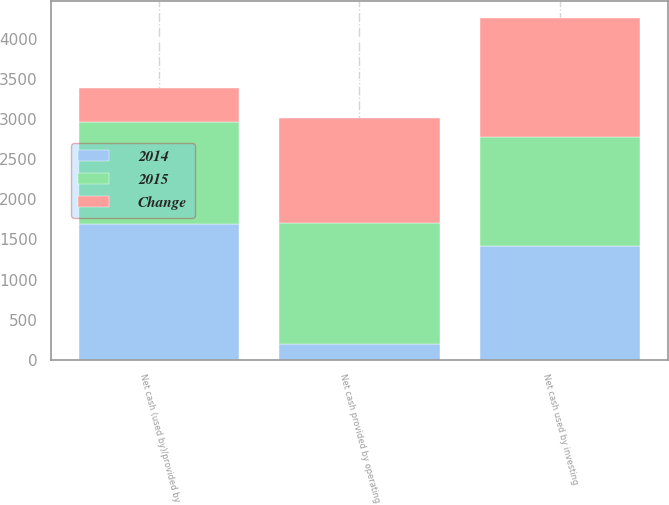<chart> <loc_0><loc_0><loc_500><loc_500><stacked_bar_chart><ecel><fcel>Net cash provided by operating<fcel>Net cash used by investing<fcel>Net cash (used by)/provided by<nl><fcel>Change<fcel>1309<fcel>1485<fcel>432<nl><fcel>2015<fcel>1510<fcel>1363.5<fcel>1265<nl><fcel>2014<fcel>201<fcel>1418<fcel>1697<nl></chart> 